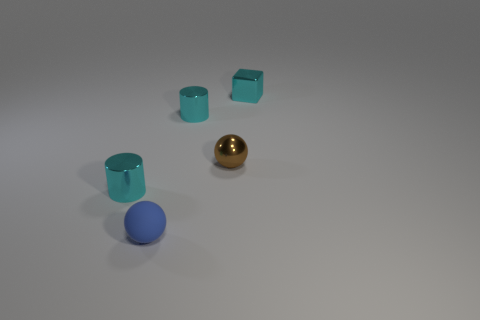Add 4 small brown balls. How many objects exist? 9 Subtract all cylinders. How many objects are left? 3 Add 1 brown shiny things. How many brown shiny things are left? 2 Add 4 blue spheres. How many blue spheres exist? 5 Subtract 0 green blocks. How many objects are left? 5 Subtract all brown metallic things. Subtract all small shiny spheres. How many objects are left? 3 